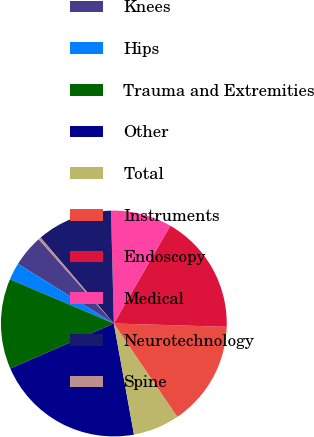Convert chart. <chart><loc_0><loc_0><loc_500><loc_500><pie_chart><fcel>Knees<fcel>Hips<fcel>Trauma and Extremities<fcel>Other<fcel>Total<fcel>Instruments<fcel>Endoscopy<fcel>Medical<fcel>Neurotechnology<fcel>Spine<nl><fcel>4.55%<fcel>2.45%<fcel>12.94%<fcel>21.32%<fcel>6.65%<fcel>15.03%<fcel>17.13%<fcel>8.74%<fcel>10.84%<fcel>0.36%<nl></chart> 